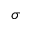<formula> <loc_0><loc_0><loc_500><loc_500>\sigma</formula> 